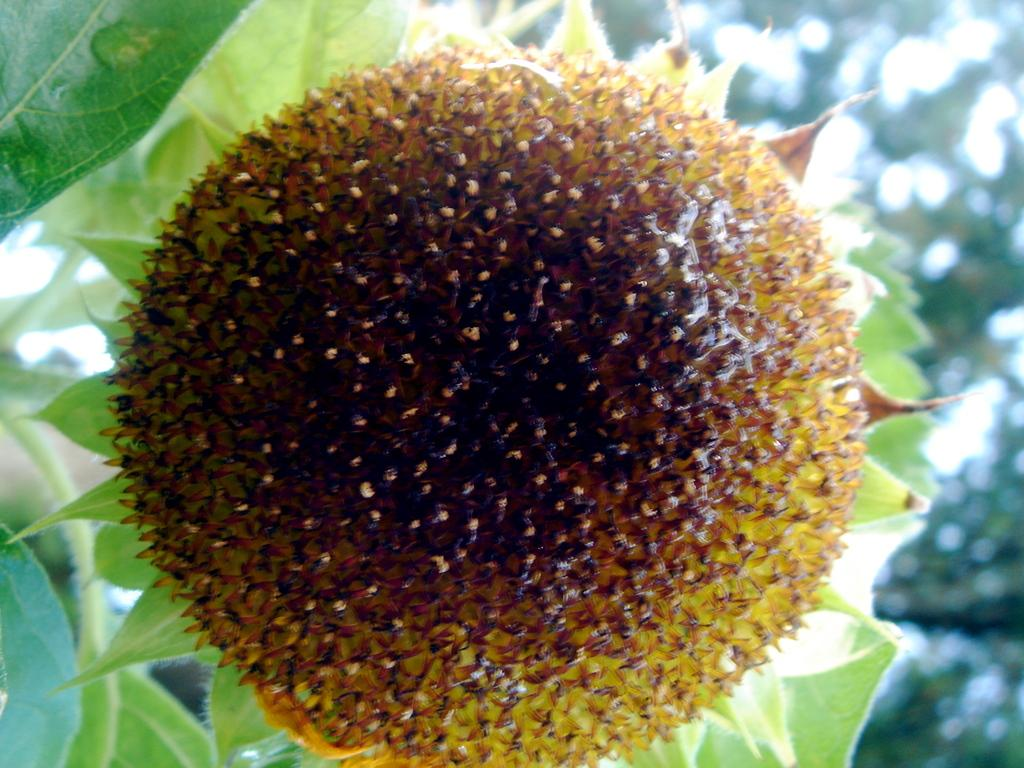What is the main subject of the image? The main subject of the image is pollen grains of a flower. Where are the pollen grains located? The pollen grains are present on a plant. What type of skirt is visible in the image? There is no skirt present in the image; it features pollen grains of a flower on a plant. How many yaks can be seen grazing in the background of the image? There are no yaks present in the image; it features pollen grains of a flower on a plant. 